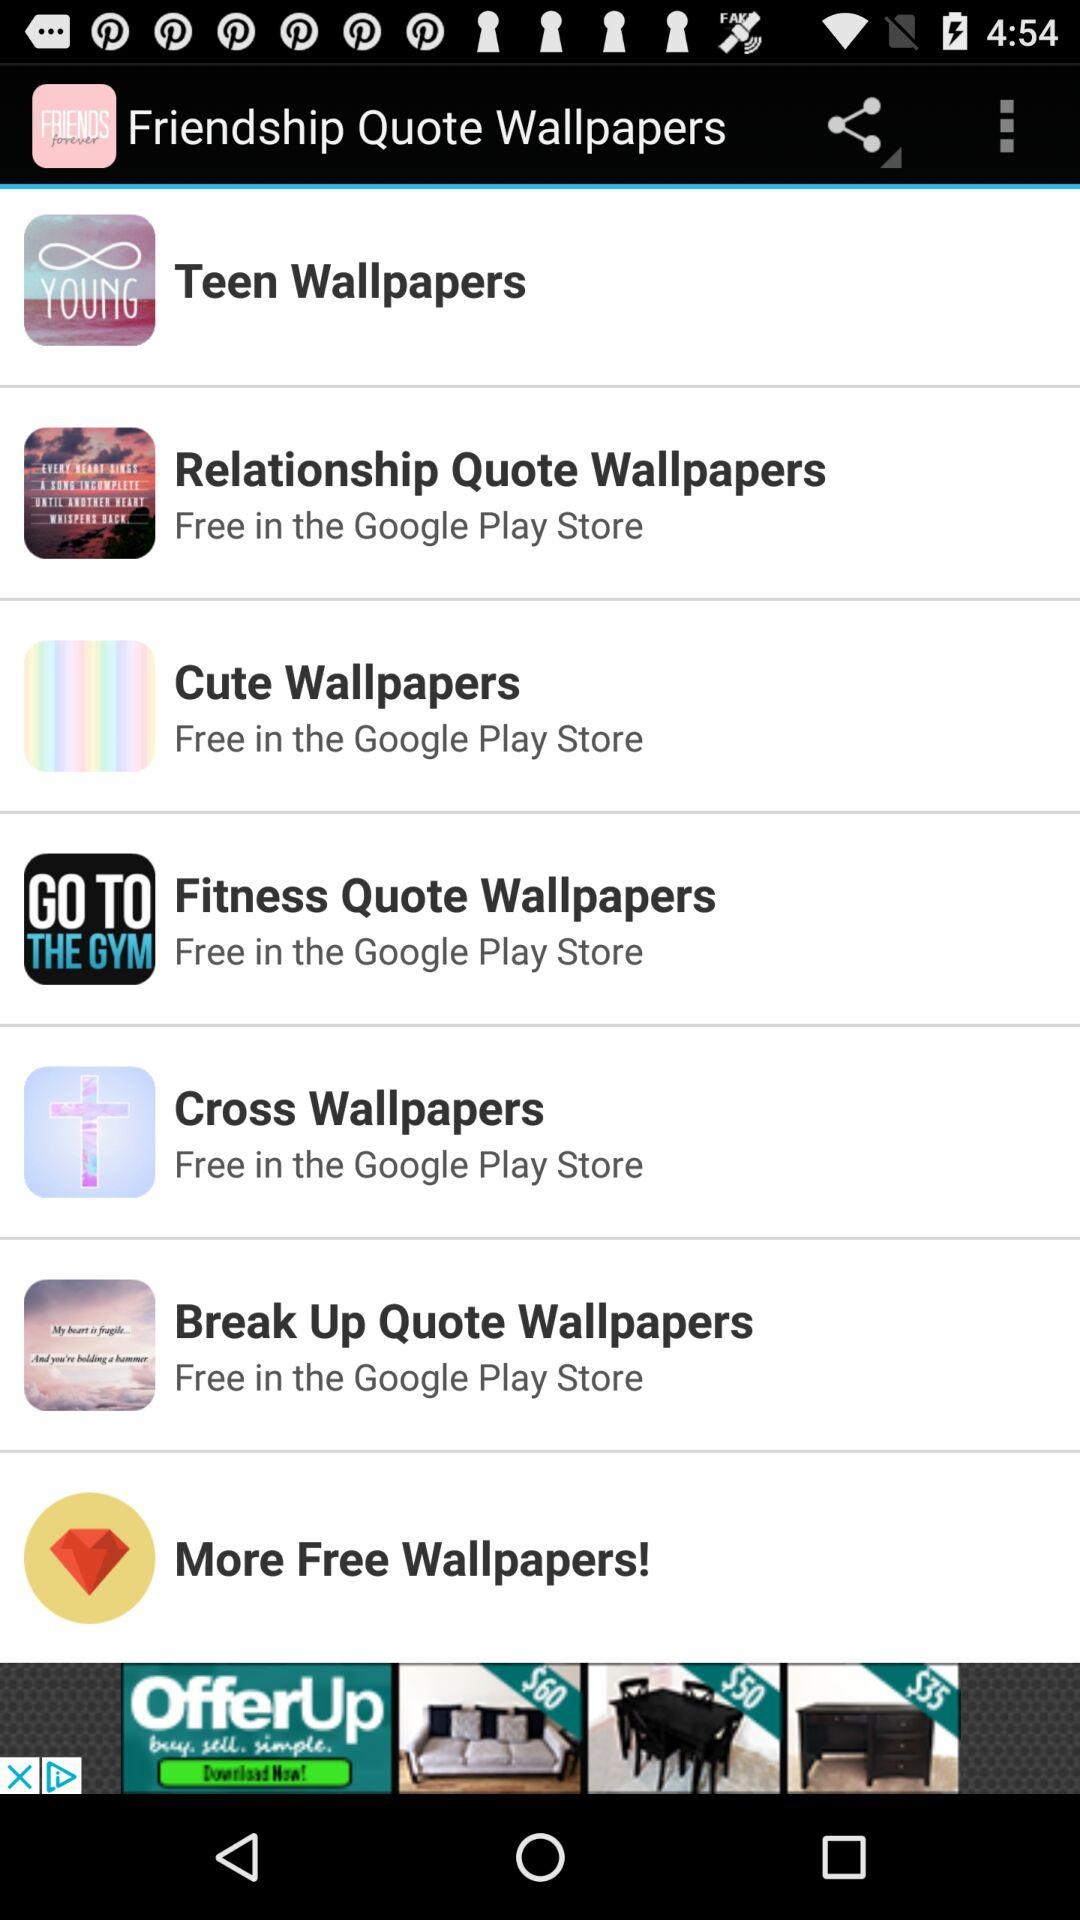Where can I get free "Cute Wallpapers"? You can get free "Cute Wallpapers" in the "Google Play Store". 